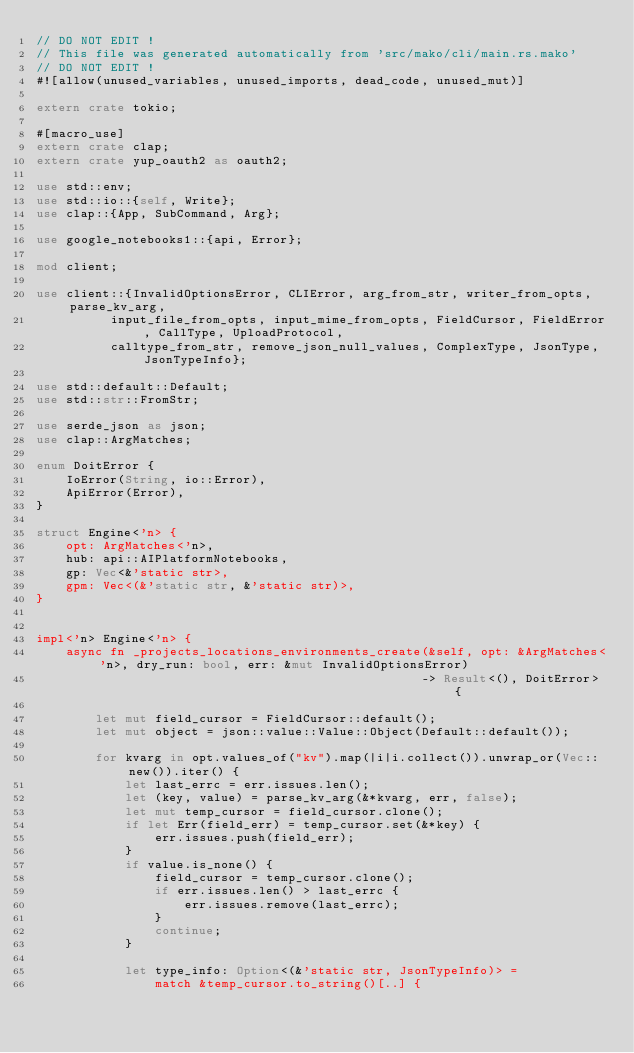<code> <loc_0><loc_0><loc_500><loc_500><_Rust_>// DO NOT EDIT !
// This file was generated automatically from 'src/mako/cli/main.rs.mako'
// DO NOT EDIT !
#![allow(unused_variables, unused_imports, dead_code, unused_mut)]

extern crate tokio;

#[macro_use]
extern crate clap;
extern crate yup_oauth2 as oauth2;

use std::env;
use std::io::{self, Write};
use clap::{App, SubCommand, Arg};

use google_notebooks1::{api, Error};

mod client;

use client::{InvalidOptionsError, CLIError, arg_from_str, writer_from_opts, parse_kv_arg,
          input_file_from_opts, input_mime_from_opts, FieldCursor, FieldError, CallType, UploadProtocol,
          calltype_from_str, remove_json_null_values, ComplexType, JsonType, JsonTypeInfo};

use std::default::Default;
use std::str::FromStr;

use serde_json as json;
use clap::ArgMatches;

enum DoitError {
    IoError(String, io::Error),
    ApiError(Error),
}

struct Engine<'n> {
    opt: ArgMatches<'n>,
    hub: api::AIPlatformNotebooks,
    gp: Vec<&'static str>,
    gpm: Vec<(&'static str, &'static str)>,
}


impl<'n> Engine<'n> {
    async fn _projects_locations_environments_create(&self, opt: &ArgMatches<'n>, dry_run: bool, err: &mut InvalidOptionsError)
                                                    -> Result<(), DoitError> {
        
        let mut field_cursor = FieldCursor::default();
        let mut object = json::value::Value::Object(Default::default());
        
        for kvarg in opt.values_of("kv").map(|i|i.collect()).unwrap_or(Vec::new()).iter() {
            let last_errc = err.issues.len();
            let (key, value) = parse_kv_arg(&*kvarg, err, false);
            let mut temp_cursor = field_cursor.clone();
            if let Err(field_err) = temp_cursor.set(&*key) {
                err.issues.push(field_err);
            }
            if value.is_none() {
                field_cursor = temp_cursor.clone();
                if err.issues.len() > last_errc {
                    err.issues.remove(last_errc);
                }
                continue;
            }
        
            let type_info: Option<(&'static str, JsonTypeInfo)> =
                match &temp_cursor.to_string()[..] {</code> 